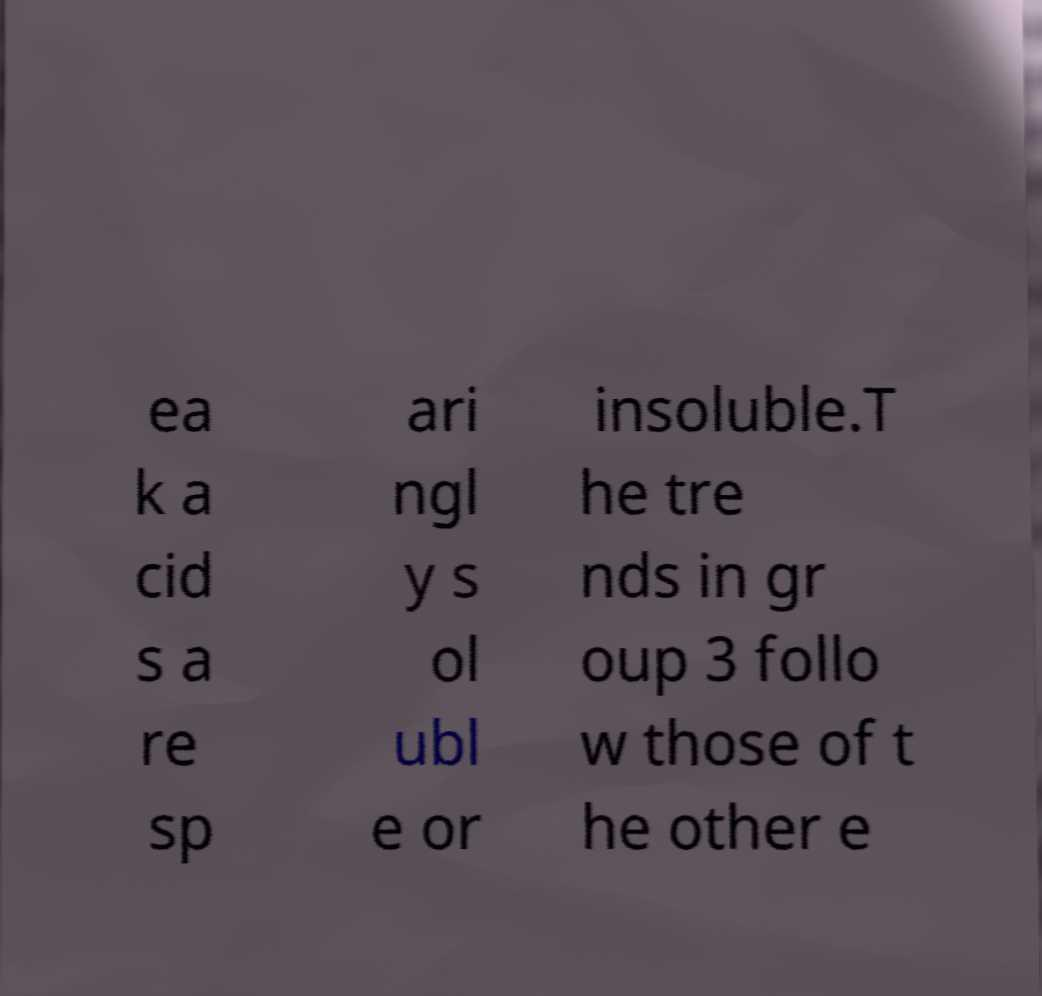Can you read and provide the text displayed in the image?This photo seems to have some interesting text. Can you extract and type it out for me? ea k a cid s a re sp ari ngl y s ol ubl e or insoluble.T he tre nds in gr oup 3 follo w those of t he other e 